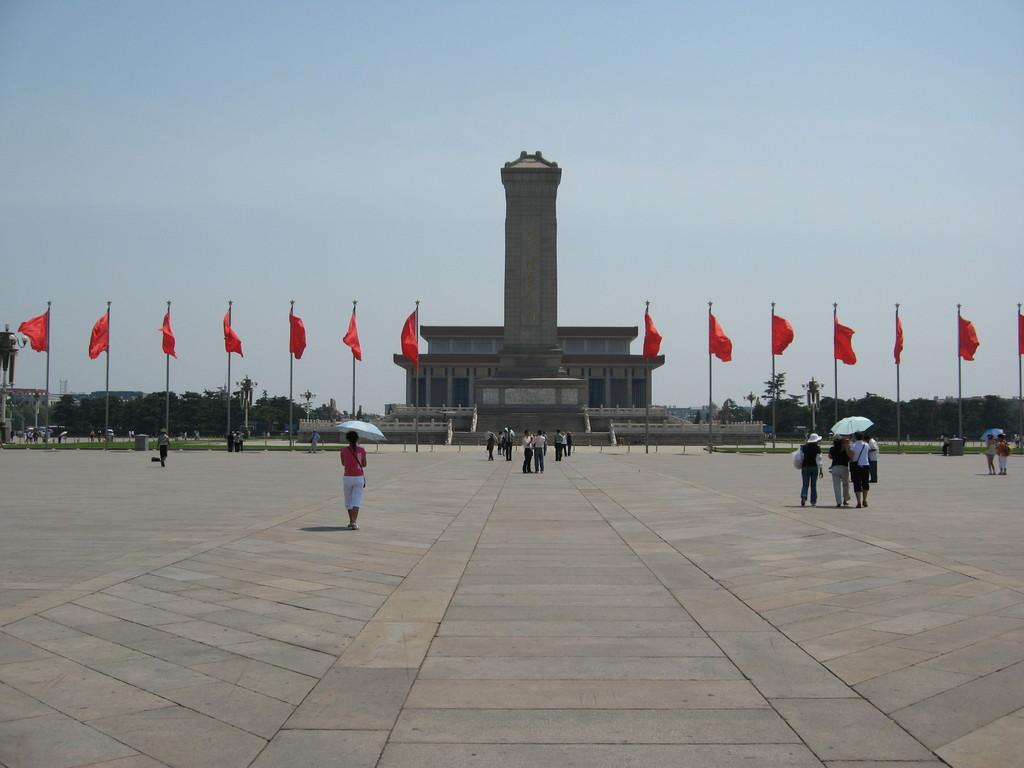What can be seen on the right side of the image? There are people on the right side of the image. What can be seen on the left side of the image? There are people on the left side of the image. What is located in the center of the image? There is a building, flags, and trees in the center of the image. How many sheep are present in the image? There are no sheep present in the image. What are the people in the image paying attention to? The provided facts do not mention what the people are paying attention to, so we cannot definitively answer this question. 